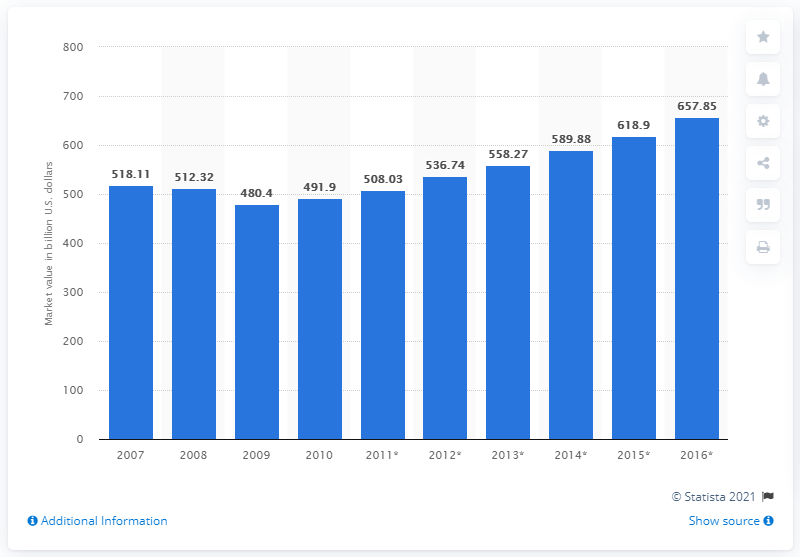List a handful of essential elements in this visual. In 2010, the North American entertainment and media market was worth an estimated 491.9 billion dollars. 